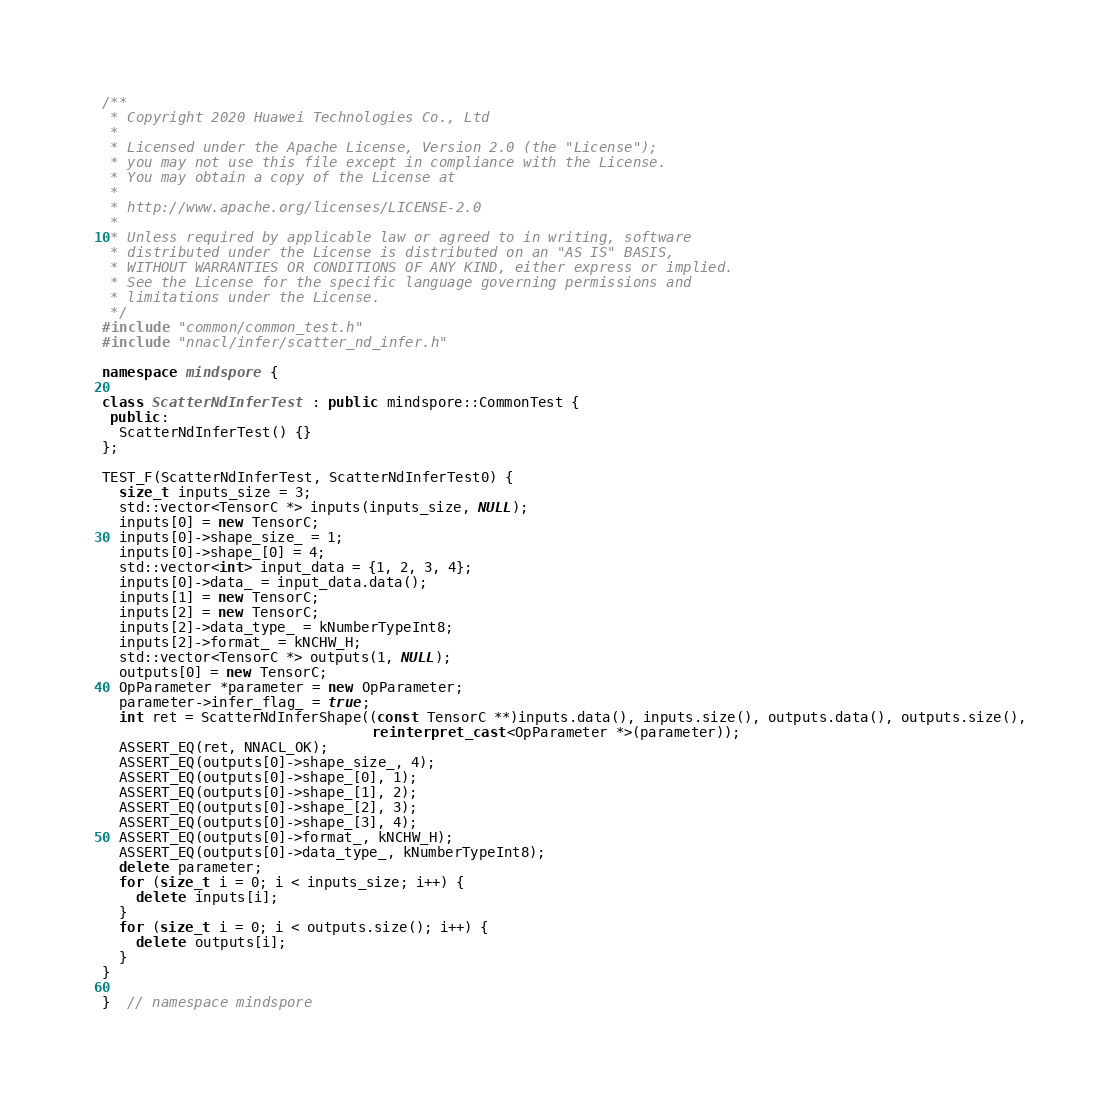<code> <loc_0><loc_0><loc_500><loc_500><_C++_>/**
 * Copyright 2020 Huawei Technologies Co., Ltd
 *
 * Licensed under the Apache License, Version 2.0 (the "License");
 * you may not use this file except in compliance with the License.
 * You may obtain a copy of the License at
 *
 * http://www.apache.org/licenses/LICENSE-2.0
 *
 * Unless required by applicable law or agreed to in writing, software
 * distributed under the License is distributed on an "AS IS" BASIS,
 * WITHOUT WARRANTIES OR CONDITIONS OF ANY KIND, either express or implied.
 * See the License for the specific language governing permissions and
 * limitations under the License.
 */
#include "common/common_test.h"
#include "nnacl/infer/scatter_nd_infer.h"

namespace mindspore {

class ScatterNdInferTest : public mindspore::CommonTest {
 public:
  ScatterNdInferTest() {}
};

TEST_F(ScatterNdInferTest, ScatterNdInferTest0) {
  size_t inputs_size = 3;
  std::vector<TensorC *> inputs(inputs_size, NULL);
  inputs[0] = new TensorC;
  inputs[0]->shape_size_ = 1;
  inputs[0]->shape_[0] = 4;
  std::vector<int> input_data = {1, 2, 3, 4};
  inputs[0]->data_ = input_data.data();
  inputs[1] = new TensorC;
  inputs[2] = new TensorC;
  inputs[2]->data_type_ = kNumberTypeInt8;
  inputs[2]->format_ = kNCHW_H;
  std::vector<TensorC *> outputs(1, NULL);
  outputs[0] = new TensorC;
  OpParameter *parameter = new OpParameter;
  parameter->infer_flag_ = true;
  int ret = ScatterNdInferShape((const TensorC **)inputs.data(), inputs.size(), outputs.data(), outputs.size(),
                                reinterpret_cast<OpParameter *>(parameter));
  ASSERT_EQ(ret, NNACL_OK);
  ASSERT_EQ(outputs[0]->shape_size_, 4);
  ASSERT_EQ(outputs[0]->shape_[0], 1);
  ASSERT_EQ(outputs[0]->shape_[1], 2);
  ASSERT_EQ(outputs[0]->shape_[2], 3);
  ASSERT_EQ(outputs[0]->shape_[3], 4);
  ASSERT_EQ(outputs[0]->format_, kNCHW_H);
  ASSERT_EQ(outputs[0]->data_type_, kNumberTypeInt8);
  delete parameter;
  for (size_t i = 0; i < inputs_size; i++) {
    delete inputs[i];
  }
  for (size_t i = 0; i < outputs.size(); i++) {
    delete outputs[i];
  }
}

}  // namespace mindspore
</code> 